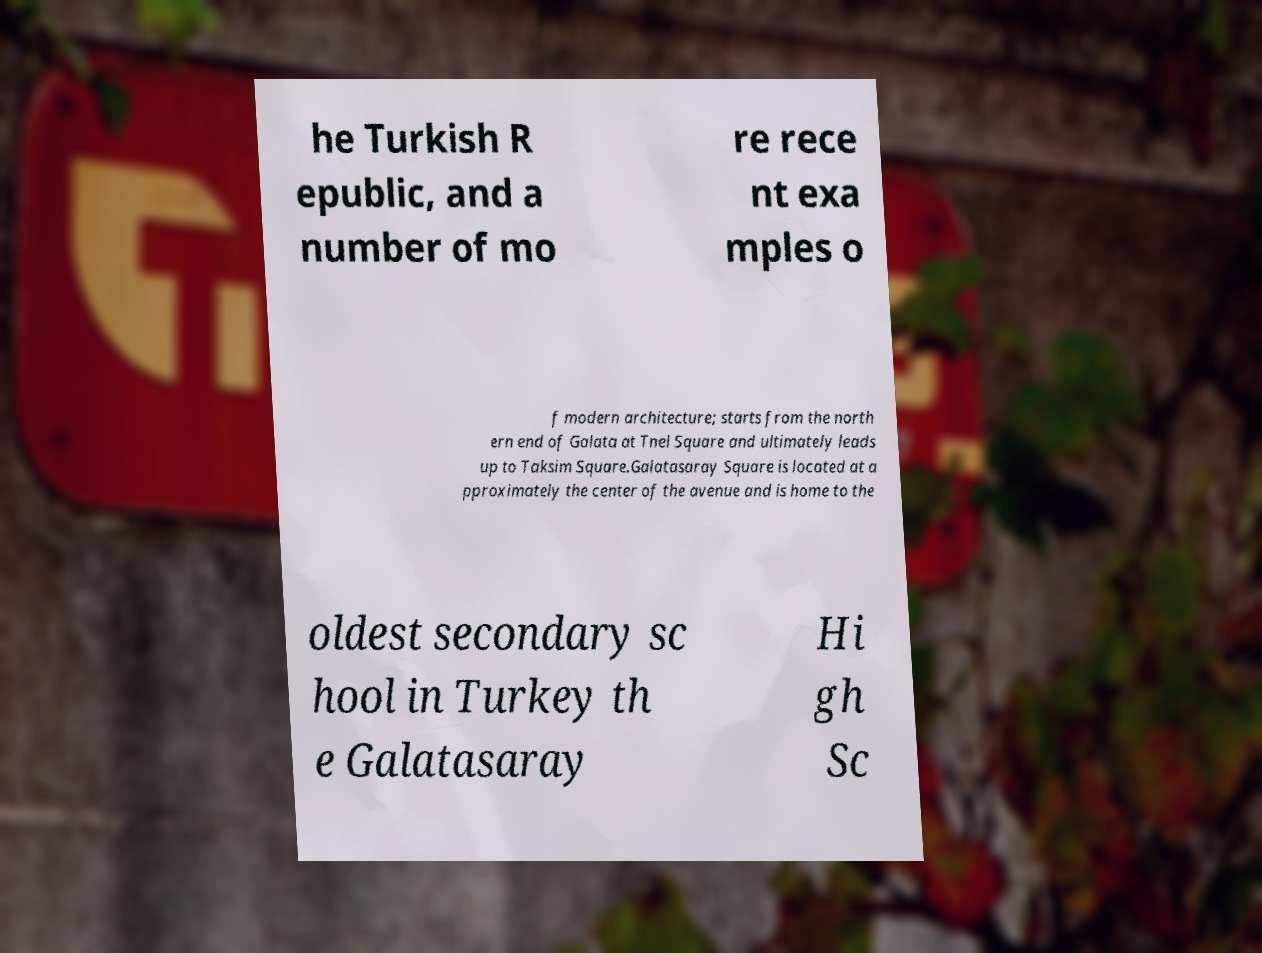Could you assist in decoding the text presented in this image and type it out clearly? he Turkish R epublic, and a number of mo re rece nt exa mples o f modern architecture; starts from the north ern end of Galata at Tnel Square and ultimately leads up to Taksim Square.Galatasaray Square is located at a pproximately the center of the avenue and is home to the oldest secondary sc hool in Turkey th e Galatasaray Hi gh Sc 